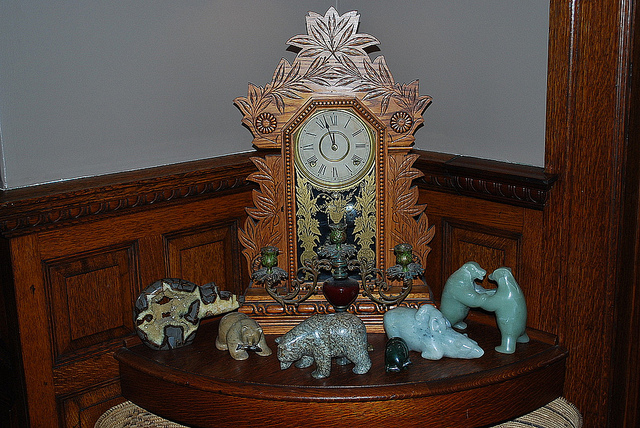<image>What's the bird atop the clock? It is not clear what bird is atop the clock. It could be a bluebird or a sparrow, or there might be no bird at all. What's the bird atop the clock? I am not sure what bird is atop the clock. It can be both bluebird or sparrow. 